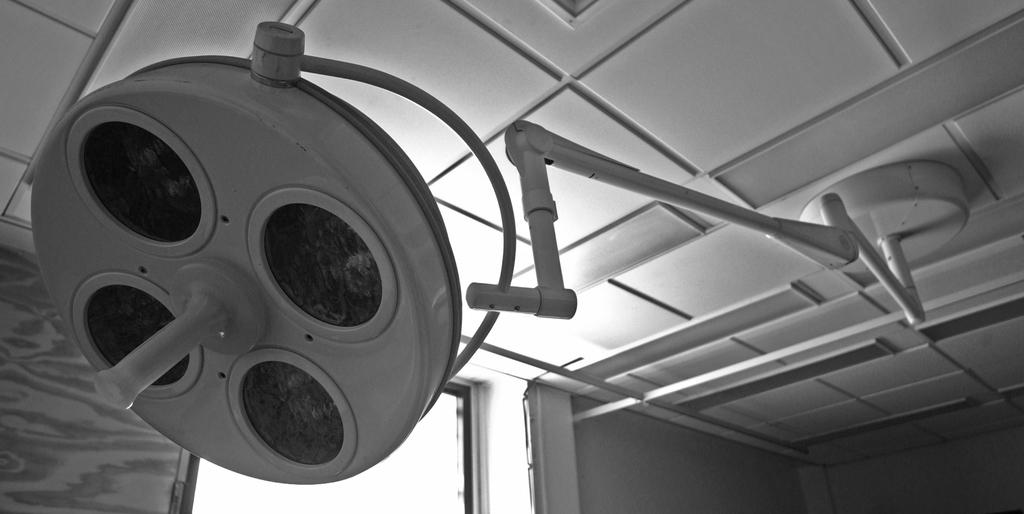What is the main object in the image that is attached to a stand? There is an object with four lights on it in the image. Can you describe the object's surroundings? There is a roof and a wall visible in the image. What type of zephyr can be seen blowing through the lights in the image? There is no zephyr present in the image, and the lights are not affected by any wind or breeze. 